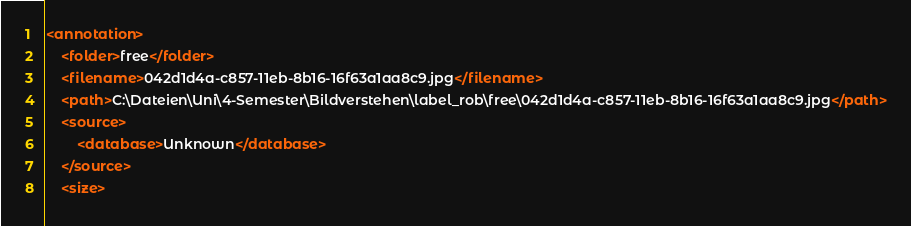<code> <loc_0><loc_0><loc_500><loc_500><_XML_><annotation>
	<folder>free</folder>
	<filename>042d1d4a-c857-11eb-8b16-16f63a1aa8c9.jpg</filename>
	<path>C:\Dateien\Uni\4-Semester\Bildverstehen\label_rob\free\042d1d4a-c857-11eb-8b16-16f63a1aa8c9.jpg</path>
	<source>
		<database>Unknown</database>
	</source>
	<size></code> 